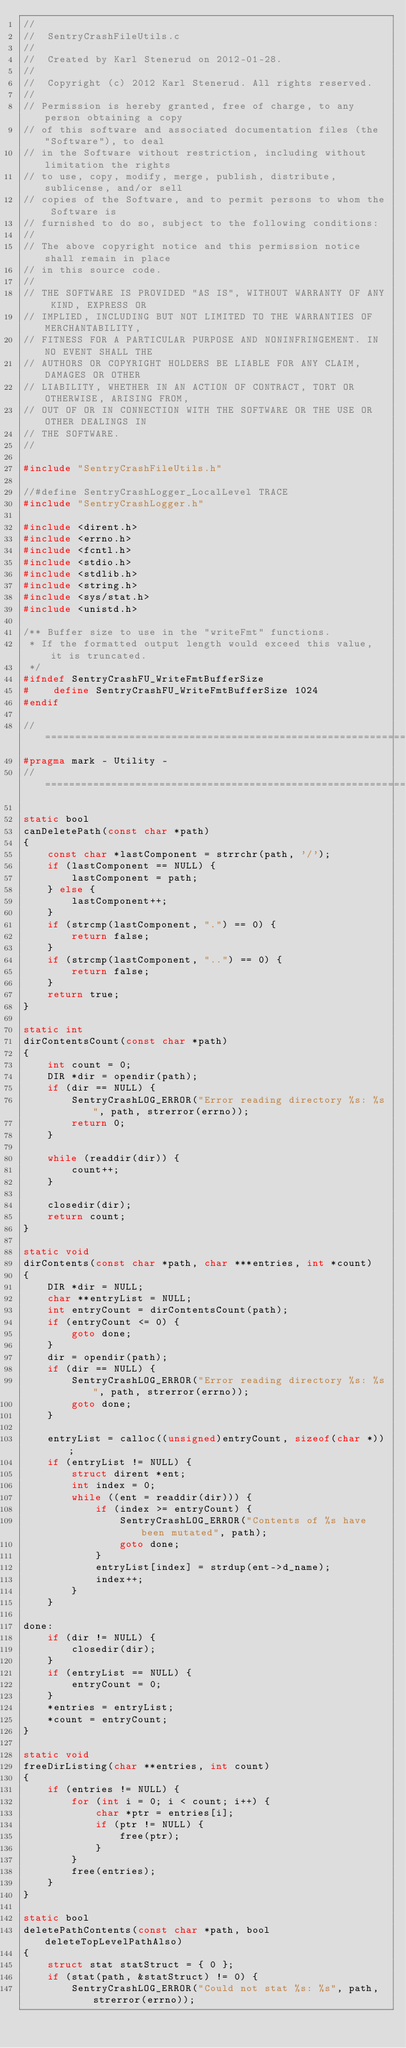Convert code to text. <code><loc_0><loc_0><loc_500><loc_500><_C_>//
//  SentryCrashFileUtils.c
//
//  Created by Karl Stenerud on 2012-01-28.
//
//  Copyright (c) 2012 Karl Stenerud. All rights reserved.
//
// Permission is hereby granted, free of charge, to any person obtaining a copy
// of this software and associated documentation files (the "Software"), to deal
// in the Software without restriction, including without limitation the rights
// to use, copy, modify, merge, publish, distribute, sublicense, and/or sell
// copies of the Software, and to permit persons to whom the Software is
// furnished to do so, subject to the following conditions:
//
// The above copyright notice and this permission notice shall remain in place
// in this source code.
//
// THE SOFTWARE IS PROVIDED "AS IS", WITHOUT WARRANTY OF ANY KIND, EXPRESS OR
// IMPLIED, INCLUDING BUT NOT LIMITED TO THE WARRANTIES OF MERCHANTABILITY,
// FITNESS FOR A PARTICULAR PURPOSE AND NONINFRINGEMENT. IN NO EVENT SHALL THE
// AUTHORS OR COPYRIGHT HOLDERS BE LIABLE FOR ANY CLAIM, DAMAGES OR OTHER
// LIABILITY, WHETHER IN AN ACTION OF CONTRACT, TORT OR OTHERWISE, ARISING FROM,
// OUT OF OR IN CONNECTION WITH THE SOFTWARE OR THE USE OR OTHER DEALINGS IN
// THE SOFTWARE.
//

#include "SentryCrashFileUtils.h"

//#define SentryCrashLogger_LocalLevel TRACE
#include "SentryCrashLogger.h"

#include <dirent.h>
#include <errno.h>
#include <fcntl.h>
#include <stdio.h>
#include <stdlib.h>
#include <string.h>
#include <sys/stat.h>
#include <unistd.h>

/** Buffer size to use in the "writeFmt" functions.
 * If the formatted output length would exceed this value, it is truncated.
 */
#ifndef SentryCrashFU_WriteFmtBufferSize
#    define SentryCrashFU_WriteFmtBufferSize 1024
#endif

// ============================================================================
#pragma mark - Utility -
// ============================================================================

static bool
canDeletePath(const char *path)
{
    const char *lastComponent = strrchr(path, '/');
    if (lastComponent == NULL) {
        lastComponent = path;
    } else {
        lastComponent++;
    }
    if (strcmp(lastComponent, ".") == 0) {
        return false;
    }
    if (strcmp(lastComponent, "..") == 0) {
        return false;
    }
    return true;
}

static int
dirContentsCount(const char *path)
{
    int count = 0;
    DIR *dir = opendir(path);
    if (dir == NULL) {
        SentryCrashLOG_ERROR("Error reading directory %s: %s", path, strerror(errno));
        return 0;
    }

    while (readdir(dir)) {
        count++;
    }

    closedir(dir);
    return count;
}

static void
dirContents(const char *path, char ***entries, int *count)
{
    DIR *dir = NULL;
    char **entryList = NULL;
    int entryCount = dirContentsCount(path);
    if (entryCount <= 0) {
        goto done;
    }
    dir = opendir(path);
    if (dir == NULL) {
        SentryCrashLOG_ERROR("Error reading directory %s: %s", path, strerror(errno));
        goto done;
    }

    entryList = calloc((unsigned)entryCount, sizeof(char *));
    if (entryList != NULL) {
        struct dirent *ent;
        int index = 0;
        while ((ent = readdir(dir))) {
            if (index >= entryCount) {
                SentryCrashLOG_ERROR("Contents of %s have been mutated", path);
                goto done;
            }
            entryList[index] = strdup(ent->d_name);
            index++;
        }
    }

done:
    if (dir != NULL) {
        closedir(dir);
    }
    if (entryList == NULL) {
        entryCount = 0;
    }
    *entries = entryList;
    *count = entryCount;
}

static void
freeDirListing(char **entries, int count)
{
    if (entries != NULL) {
        for (int i = 0; i < count; i++) {
            char *ptr = entries[i];
            if (ptr != NULL) {
                free(ptr);
            }
        }
        free(entries);
    }
}

static bool
deletePathContents(const char *path, bool deleteTopLevelPathAlso)
{
    struct stat statStruct = { 0 };
    if (stat(path, &statStruct) != 0) {
        SentryCrashLOG_ERROR("Could not stat %s: %s", path, strerror(errno));</code> 